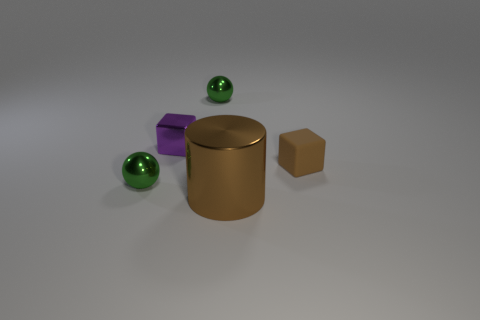Subtract all brown blocks. How many blocks are left? 1 Add 1 small gray shiny blocks. How many objects exist? 6 Subtract all blue cylinders. How many brown blocks are left? 1 Subtract all purple cubes. Subtract all blue balls. How many cubes are left? 1 Subtract all tiny green matte cylinders. Subtract all brown objects. How many objects are left? 3 Add 3 matte things. How many matte things are left? 4 Add 3 red objects. How many red objects exist? 3 Subtract 0 blue balls. How many objects are left? 5 Subtract all spheres. How many objects are left? 3 Subtract 1 cylinders. How many cylinders are left? 0 